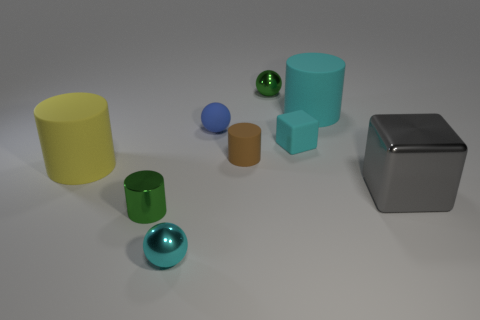What size is the metallic object that is both in front of the tiny green ball and behind the green metallic cylinder?
Offer a very short reply. Large. How many large things are either blue metallic balls or cyan rubber objects?
Your answer should be very brief. 1. What is the shape of the green thing in front of the large cyan rubber object?
Provide a succinct answer. Cylinder. How many large cyan matte objects are there?
Your answer should be compact. 1. Is the tiny block made of the same material as the large block?
Keep it short and to the point. No. Are there more cylinders that are on the right side of the small matte sphere than blue cylinders?
Keep it short and to the point. Yes. What number of objects are either green metallic spheres or small rubber objects to the left of the small brown cylinder?
Provide a short and direct response. 2. Is the number of yellow objects in front of the small green ball greater than the number of gray metal things to the left of the small rubber sphere?
Keep it short and to the point. Yes. What material is the big cylinder to the left of the tiny green shiny ball behind the green metallic object that is in front of the cyan cylinder?
Make the answer very short. Rubber. What shape is the other large object that is the same material as the yellow object?
Keep it short and to the point. Cylinder. 